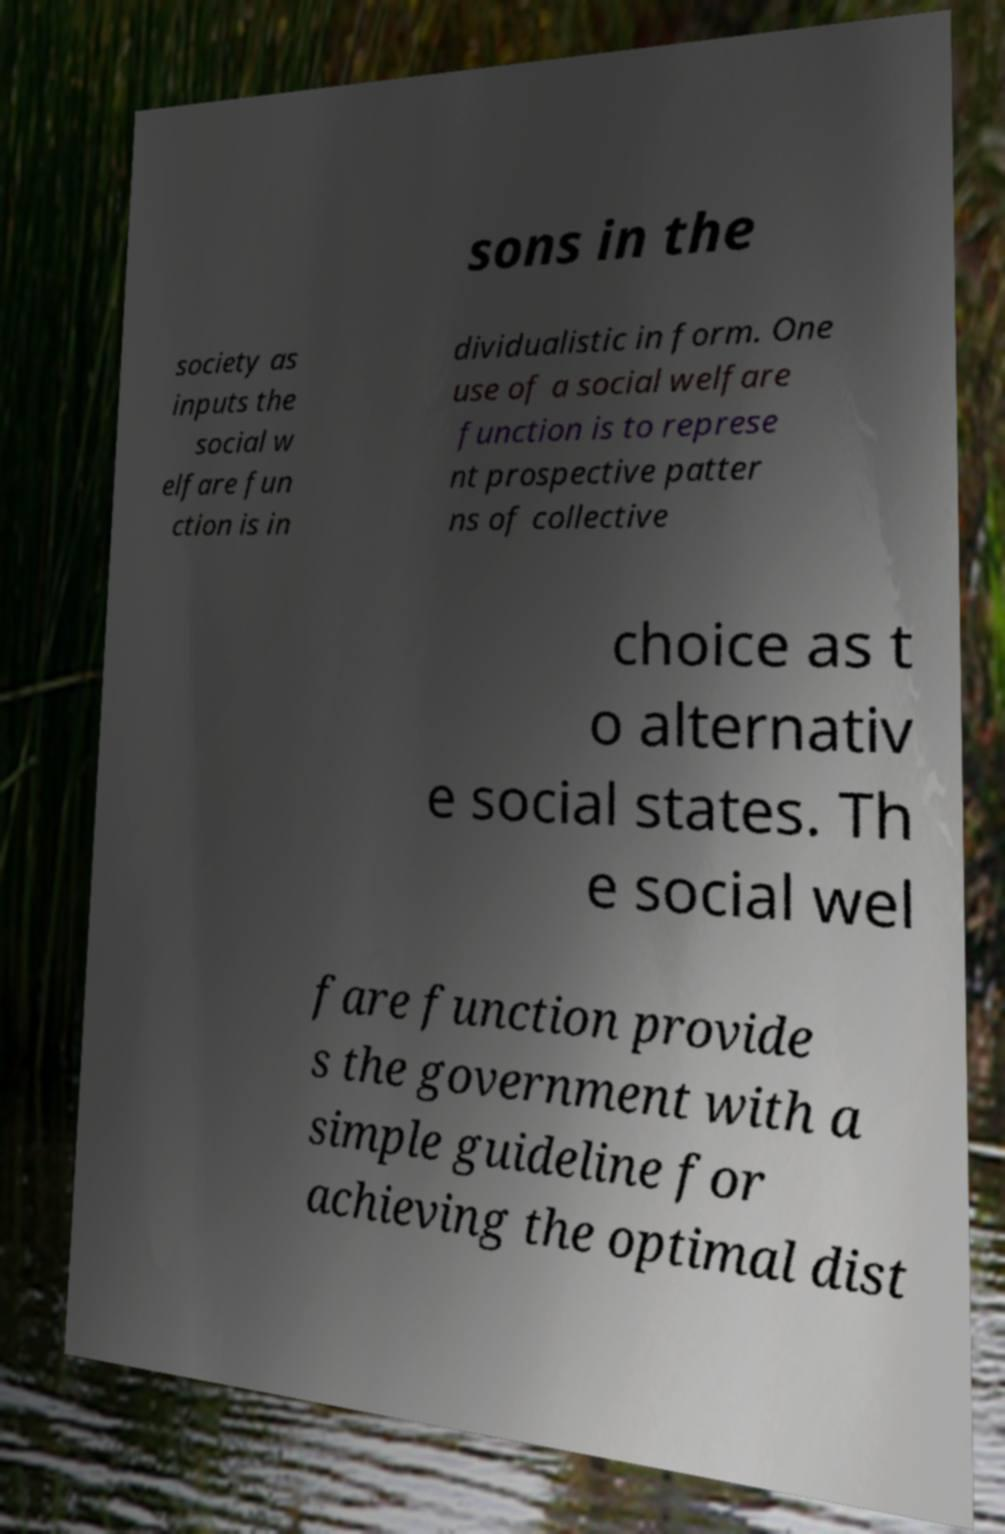Please read and relay the text visible in this image. What does it say? sons in the society as inputs the social w elfare fun ction is in dividualistic in form. One use of a social welfare function is to represe nt prospective patter ns of collective choice as t o alternativ e social states. Th e social wel fare function provide s the government with a simple guideline for achieving the optimal dist 